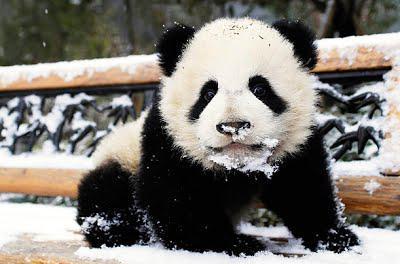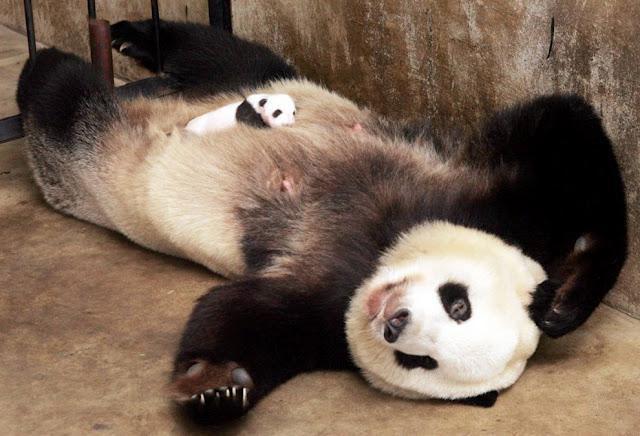The first image is the image on the left, the second image is the image on the right. Considering the images on both sides, is "One panda is eating bamboo." valid? Answer yes or no. No. The first image is the image on the left, the second image is the image on the right. Given the left and right images, does the statement "a panda is eating bamboo" hold true? Answer yes or no. No. 